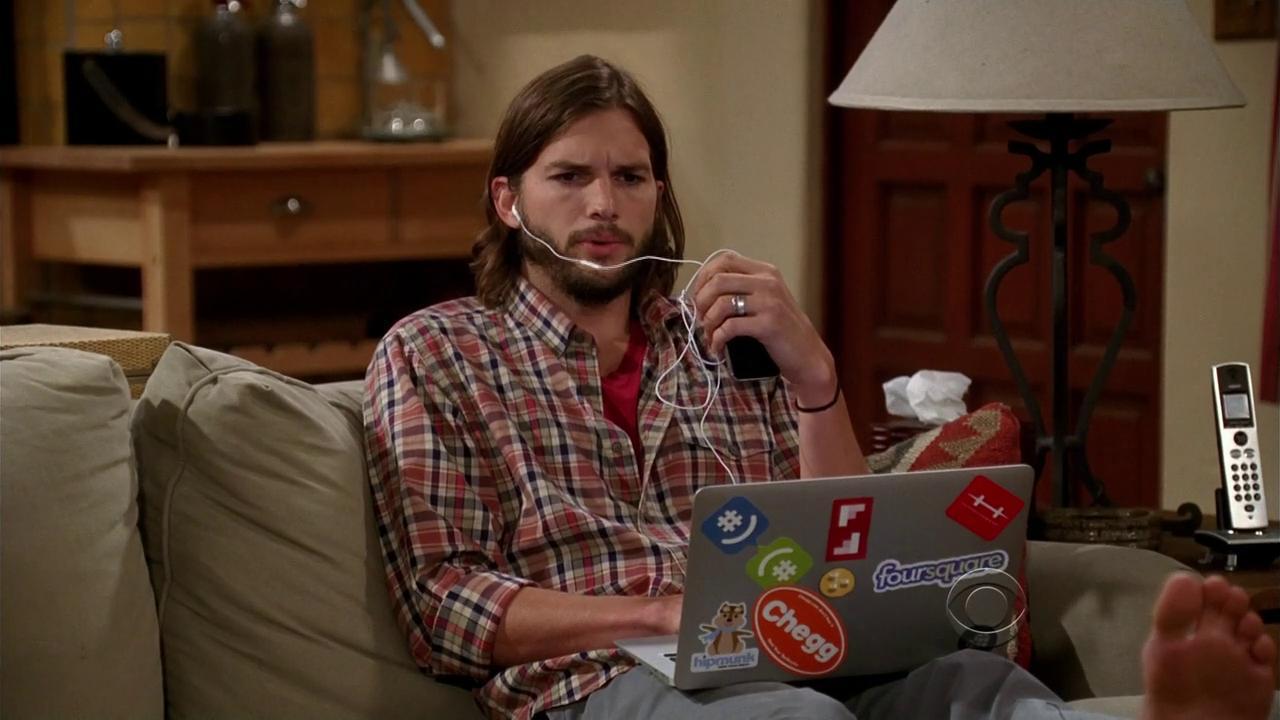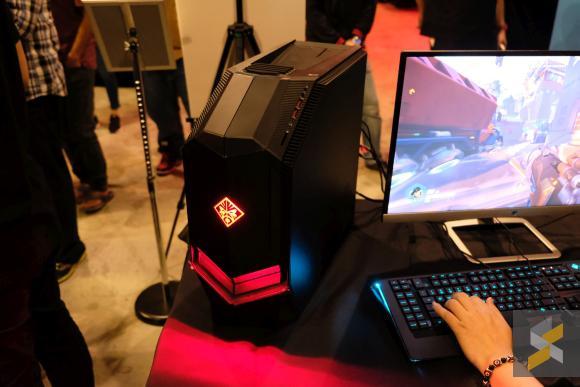The first image is the image on the left, the second image is the image on the right. For the images shown, is this caption "An image shows one man looking at an open laptop witth his feet propped up." true? Answer yes or no. Yes. The first image is the image on the left, the second image is the image on the right. For the images displayed, is the sentence "In the image to the left, we can see exactly one guy; his upper body and face are quite visible and are obvious targets of the image." factually correct? Answer yes or no. Yes. 